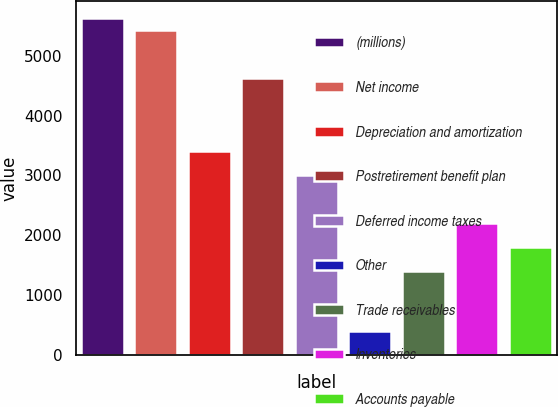Convert chart. <chart><loc_0><loc_0><loc_500><loc_500><bar_chart><fcel>(millions)<fcel>Net income<fcel>Depreciation and amortization<fcel>Postretirement benefit plan<fcel>Deferred income taxes<fcel>Other<fcel>Trade receivables<fcel>Inventories<fcel>Accounts payable<nl><fcel>5626.2<fcel>5425.3<fcel>3416.3<fcel>4621.7<fcel>3014.5<fcel>402.8<fcel>1407.3<fcel>2210.9<fcel>1809.1<nl></chart> 